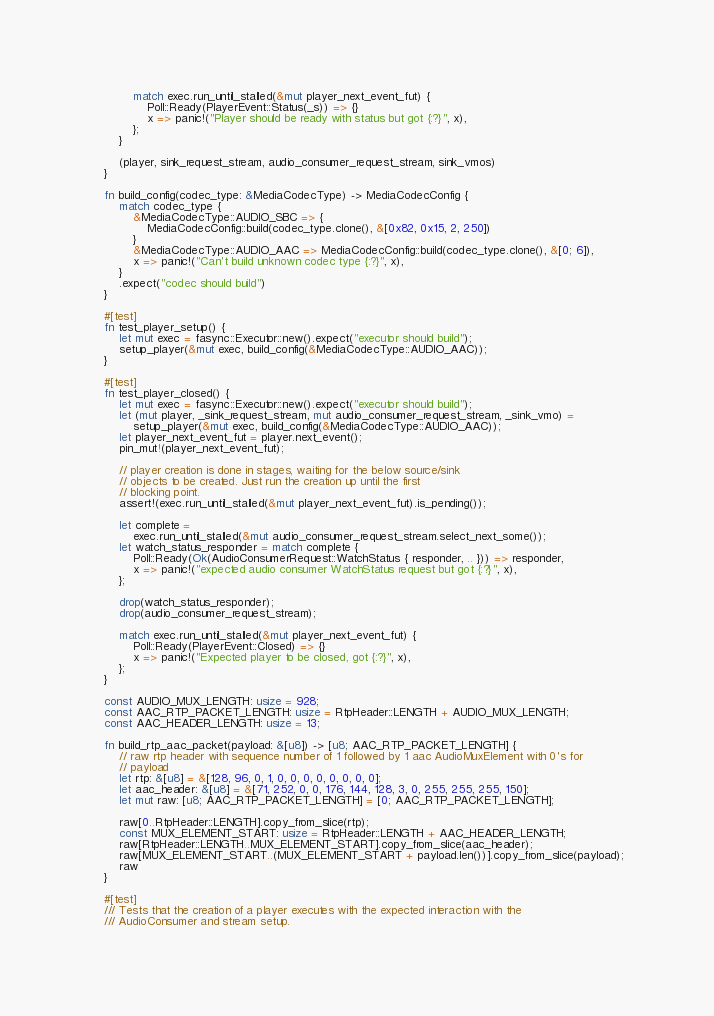Convert code to text. <code><loc_0><loc_0><loc_500><loc_500><_Rust_>            match exec.run_until_stalled(&mut player_next_event_fut) {
                Poll::Ready(PlayerEvent::Status(_s)) => {}
                x => panic!("Player should be ready with status but got {:?}", x),
            };
        }

        (player, sink_request_stream, audio_consumer_request_stream, sink_vmos)
    }

    fn build_config(codec_type: &MediaCodecType) -> MediaCodecConfig {
        match codec_type {
            &MediaCodecType::AUDIO_SBC => {
                MediaCodecConfig::build(codec_type.clone(), &[0x82, 0x15, 2, 250])
            }
            &MediaCodecType::AUDIO_AAC => MediaCodecConfig::build(codec_type.clone(), &[0; 6]),
            x => panic!("Can't build unknown codec type {:?}", x),
        }
        .expect("codec should build")
    }

    #[test]
    fn test_player_setup() {
        let mut exec = fasync::Executor::new().expect("executor should build");
        setup_player(&mut exec, build_config(&MediaCodecType::AUDIO_AAC));
    }

    #[test]
    fn test_player_closed() {
        let mut exec = fasync::Executor::new().expect("executor should build");
        let (mut player, _sink_request_stream, mut audio_consumer_request_stream, _sink_vmo) =
            setup_player(&mut exec, build_config(&MediaCodecType::AUDIO_AAC));
        let player_next_event_fut = player.next_event();
        pin_mut!(player_next_event_fut);

        // player creation is done in stages, waiting for the below source/sink
        // objects to be created. Just run the creation up until the first
        // blocking point.
        assert!(exec.run_until_stalled(&mut player_next_event_fut).is_pending());

        let complete =
            exec.run_until_stalled(&mut audio_consumer_request_stream.select_next_some());
        let watch_status_responder = match complete {
            Poll::Ready(Ok(AudioConsumerRequest::WatchStatus { responder, .. })) => responder,
            x => panic!("expected audio consumer WatchStatus request but got {:?}", x),
        };

        drop(watch_status_responder);
        drop(audio_consumer_request_stream);

        match exec.run_until_stalled(&mut player_next_event_fut) {
            Poll::Ready(PlayerEvent::Closed) => {}
            x => panic!("Expected player to be closed, got {:?}", x),
        };
    }

    const AUDIO_MUX_LENGTH: usize = 928;
    const AAC_RTP_PACKET_LENGTH: usize = RtpHeader::LENGTH + AUDIO_MUX_LENGTH;
    const AAC_HEADER_LENGTH: usize = 13;

    fn build_rtp_aac_packet(payload: &[u8]) -> [u8; AAC_RTP_PACKET_LENGTH] {
        // raw rtp header with sequence number of 1 followed by 1 aac AudioMuxElement with 0's for
        // payload
        let rtp: &[u8] = &[128, 96, 0, 1, 0, 0, 0, 0, 0, 0, 0, 0];
        let aac_header: &[u8] = &[71, 252, 0, 0, 176, 144, 128, 3, 0, 255, 255, 255, 150];
        let mut raw: [u8; AAC_RTP_PACKET_LENGTH] = [0; AAC_RTP_PACKET_LENGTH];

        raw[0..RtpHeader::LENGTH].copy_from_slice(rtp);
        const MUX_ELEMENT_START: usize = RtpHeader::LENGTH + AAC_HEADER_LENGTH;
        raw[RtpHeader::LENGTH..MUX_ELEMENT_START].copy_from_slice(aac_header);
        raw[MUX_ELEMENT_START..(MUX_ELEMENT_START + payload.len())].copy_from_slice(payload);
        raw
    }

    #[test]
    /// Tests that the creation of a player executes with the expected interaction with the
    /// AudioConsumer and stream setup.</code> 